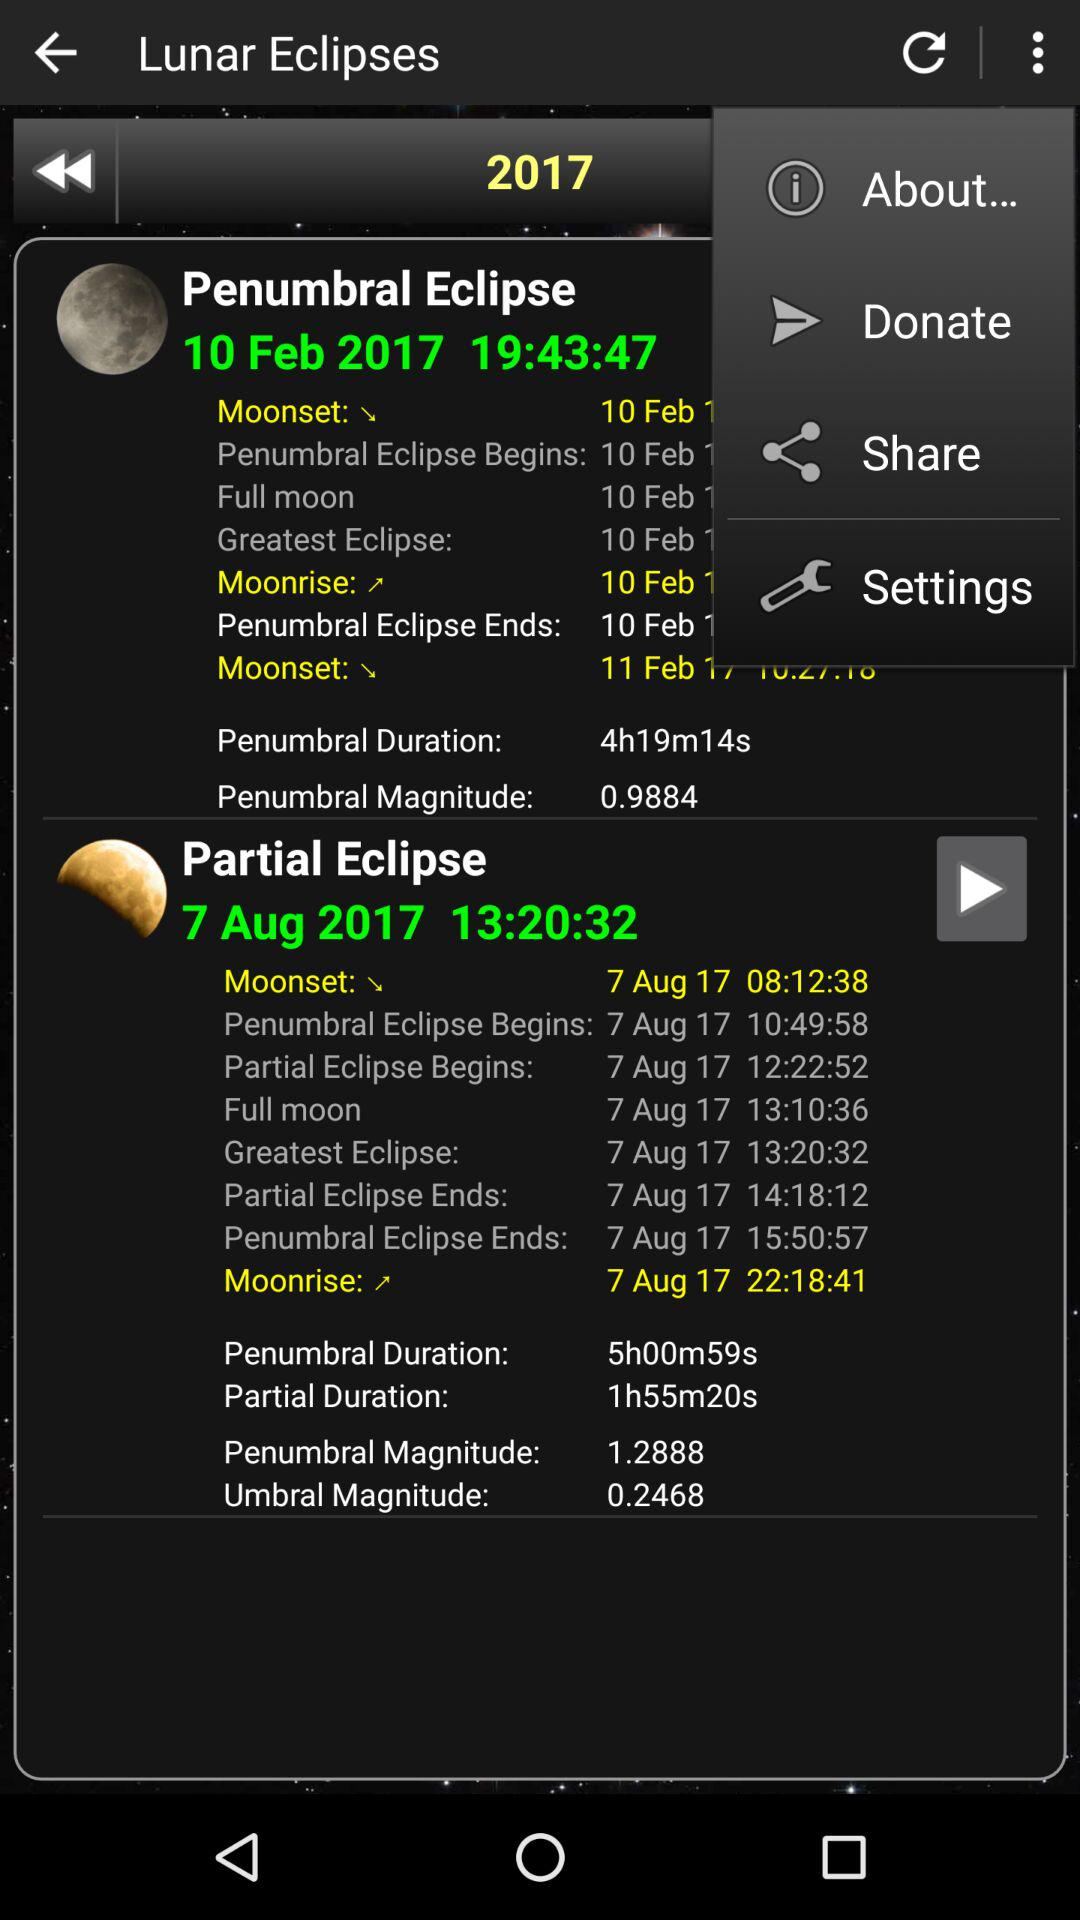What is the difference in magnitude between the penumbral and umbral eclipses?
Answer the question using a single word or phrase. 1.042 